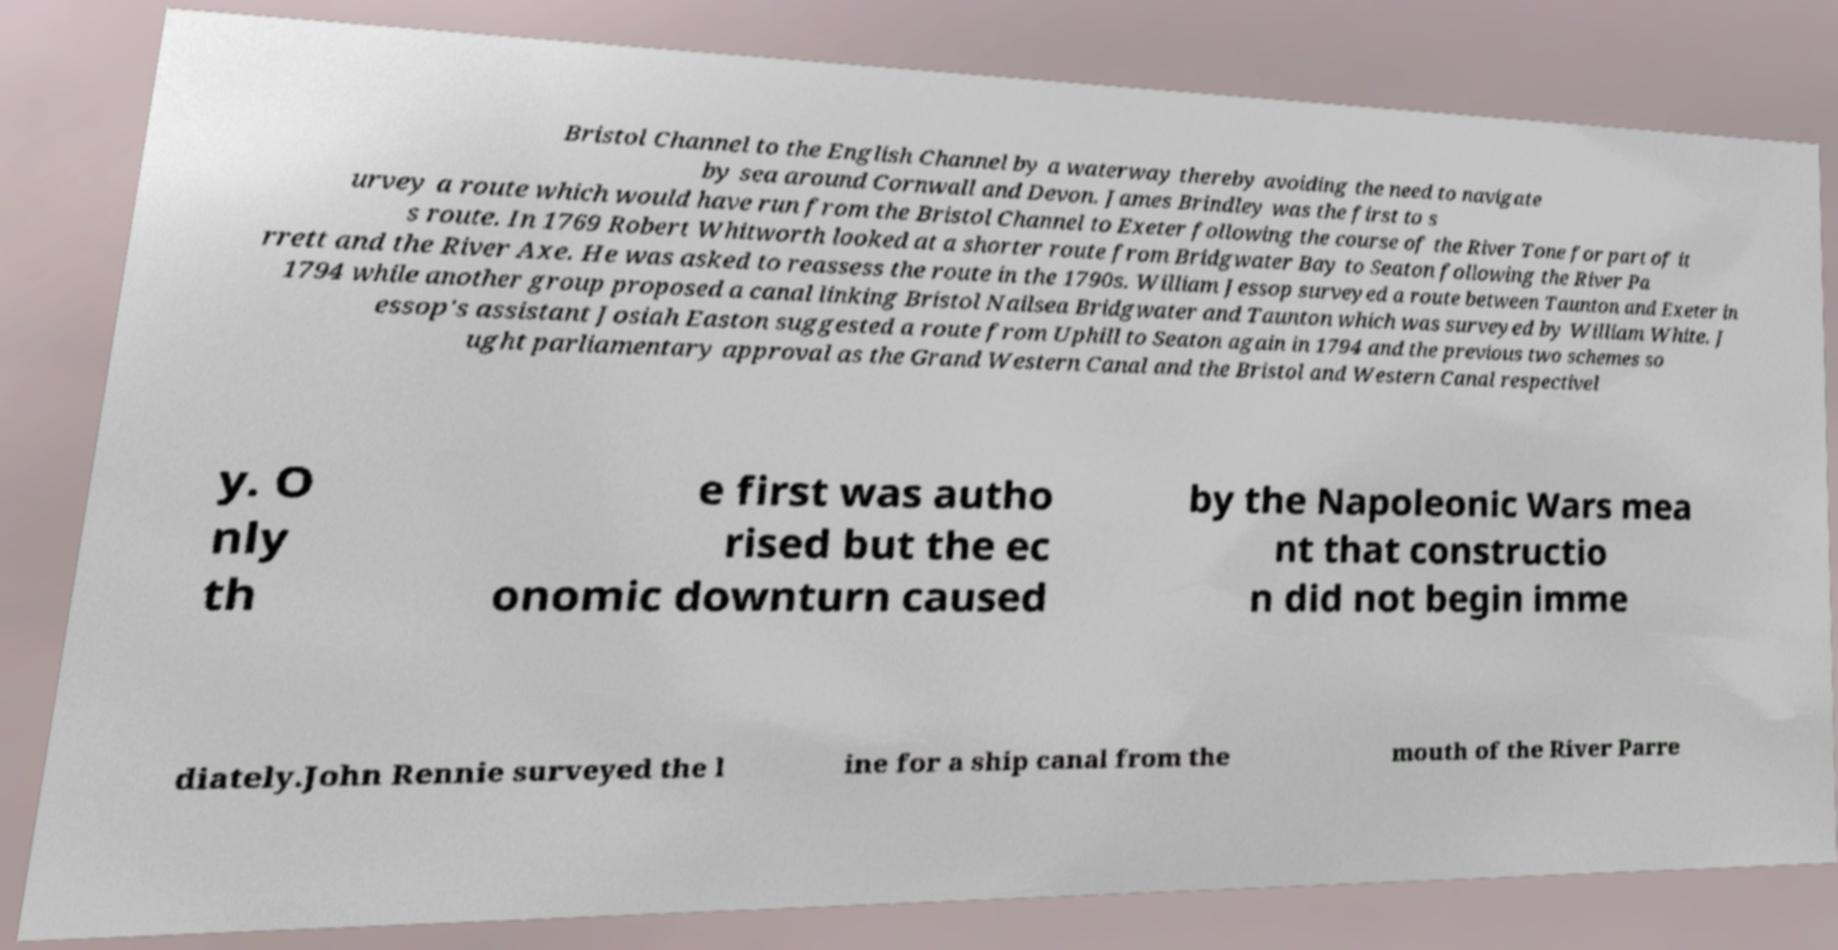For documentation purposes, I need the text within this image transcribed. Could you provide that? Bristol Channel to the English Channel by a waterway thereby avoiding the need to navigate by sea around Cornwall and Devon. James Brindley was the first to s urvey a route which would have run from the Bristol Channel to Exeter following the course of the River Tone for part of it s route. In 1769 Robert Whitworth looked at a shorter route from Bridgwater Bay to Seaton following the River Pa rrett and the River Axe. He was asked to reassess the route in the 1790s. William Jessop surveyed a route between Taunton and Exeter in 1794 while another group proposed a canal linking Bristol Nailsea Bridgwater and Taunton which was surveyed by William White. J essop's assistant Josiah Easton suggested a route from Uphill to Seaton again in 1794 and the previous two schemes so ught parliamentary approval as the Grand Western Canal and the Bristol and Western Canal respectivel y. O nly th e first was autho rised but the ec onomic downturn caused by the Napoleonic Wars mea nt that constructio n did not begin imme diately.John Rennie surveyed the l ine for a ship canal from the mouth of the River Parre 